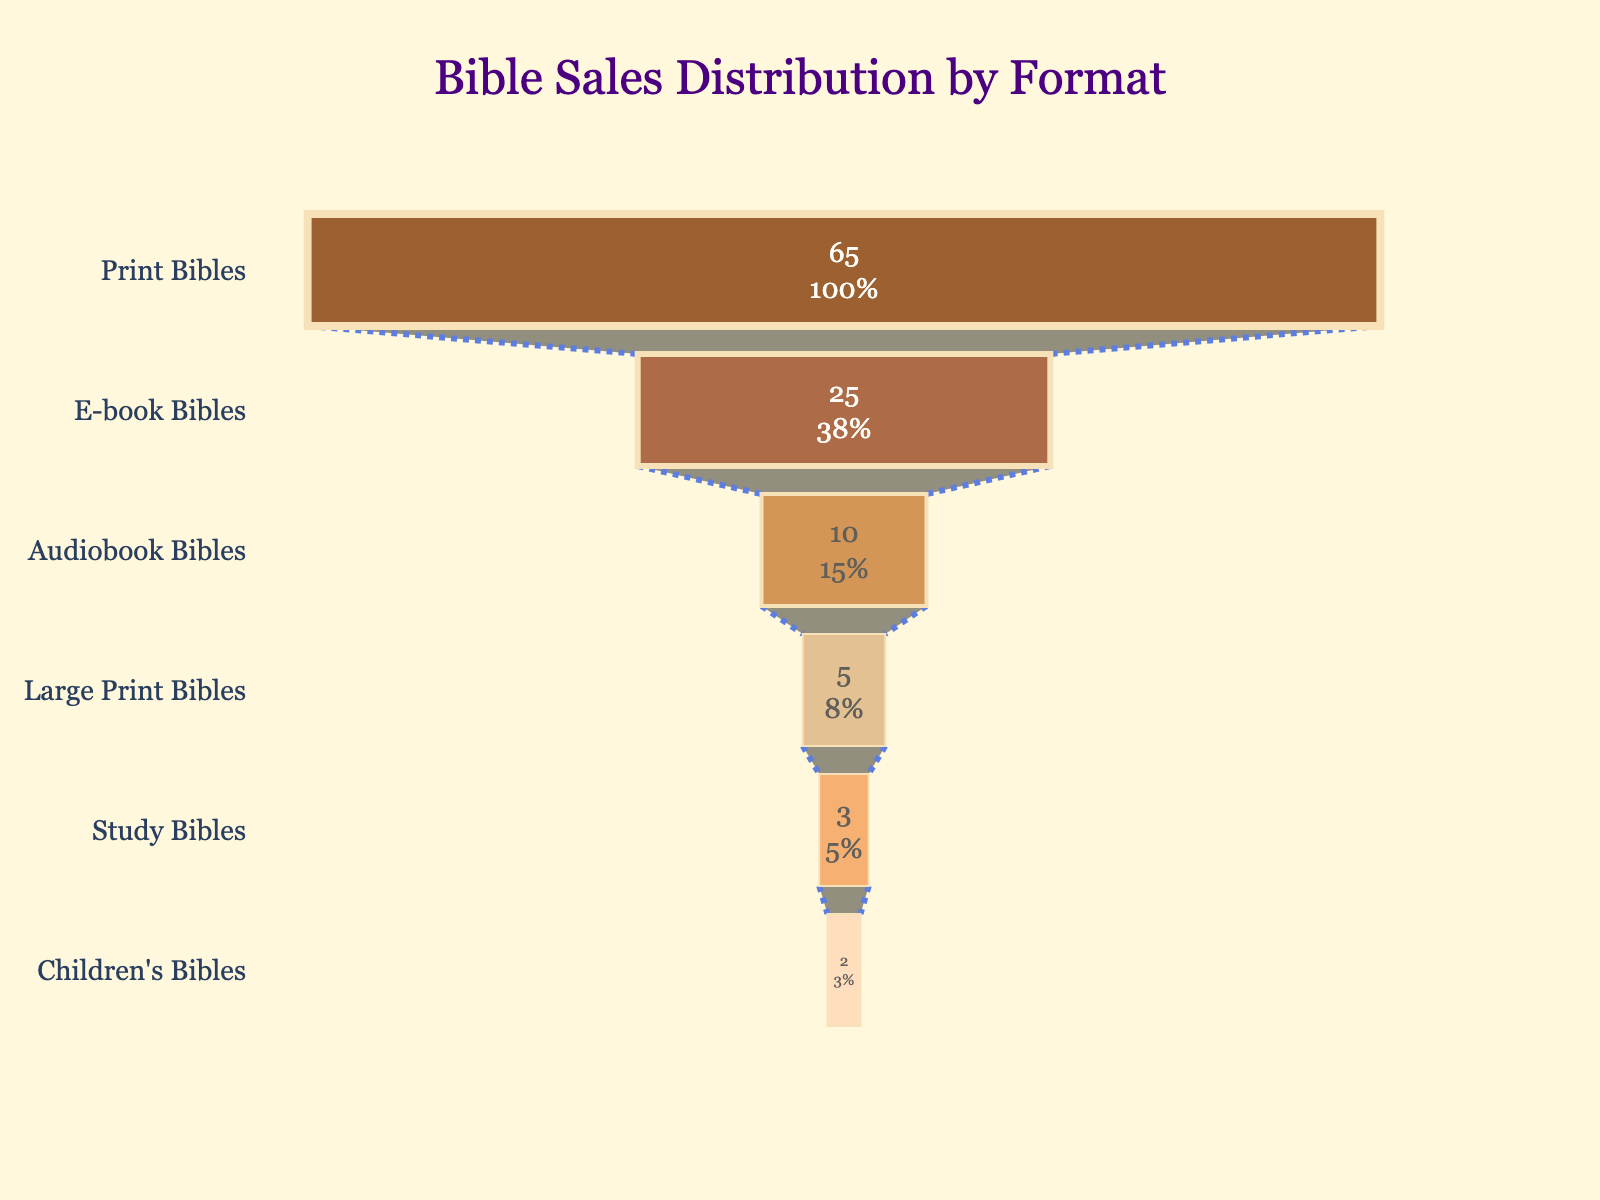What is the title of the funnel chart? The title can be determined by looking at the text at the top of the chart. It states "Bible Sales Distribution by Format".
Answer: Bible Sales Distribution by Format Which Bible format has the highest sales percentage? The highest section in the funnel chart represents the format with the highest sales percentage. It is labeled as "Print Bibles" with 65%.
Answer: Print Bibles What is the lowest sales percentage among the Bible formats? The smallest section at the bottom of the funnel chart indicates the format with the lowest sales percentage. It is labeled as "Children's Bibles" with 2%.
Answer: Children's Bibles What percentage of sales is accounted for by E-book Bibles? Looking at the funnel chart, E-book Bibles are represented as a large section and the sales percentage is labeled as 25%.
Answer: 25% How do the sales percentages for Large Print Bibles and Study Bibles compare? By examining the sizes and labels of the sections, Large Print Bibles account for 5% and Study Bibles account for 3%.
Answer: Large Print Bibles: 5%, Study Bibles: 3% What is the combined sales percentage of Audiobook Bibles and Children's Bibles? To find this, sum the sales percentages of Audiobook Bibles and Children's Bibles: 10% + 2%.
Answer: 12% Which Bible format shows a smaller sales percentage than Large Print Bibles but larger than Children's Bibles? By comparing all the sections, Study Bibles fit this condition with 3%.
Answer: Study Bibles What are the formats represented in the funnel chart? The formats are listed on the left side of each section: "Print Bibles", "E-book Bibles", "Audiobook Bibles", "Large Print Bibles", "Study Bibles", and "Children's Bibles".
Answer: Print Bibles, E-book Bibles, Audiobook Bibles, Large Print Bibles, Study Bibles, Children's Bibles What is the difference in sales percentage between the format with the highest sales and the format with the lowest sales? Subtract the sales percentage of the format with the lowest sales, Children's Bibles (2%), from the format with the highest sales, Print Bibles (65%): 65% - 2%.
Answer: 63% What is the total percentage of sales for all Bible formats combined? Sum all the sales percentages for each format: 65% + 25% + 10% + 5% + 3% + 2%.
Answer: 110% 